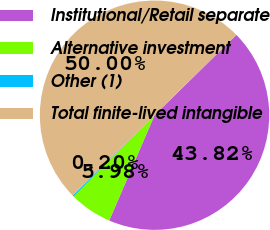<chart> <loc_0><loc_0><loc_500><loc_500><pie_chart><fcel>Institutional/Retail separate<fcel>Alternative investment<fcel>Other (1)<fcel>Total finite-lived intangible<nl><fcel>43.82%<fcel>5.98%<fcel>0.2%<fcel>50.0%<nl></chart> 